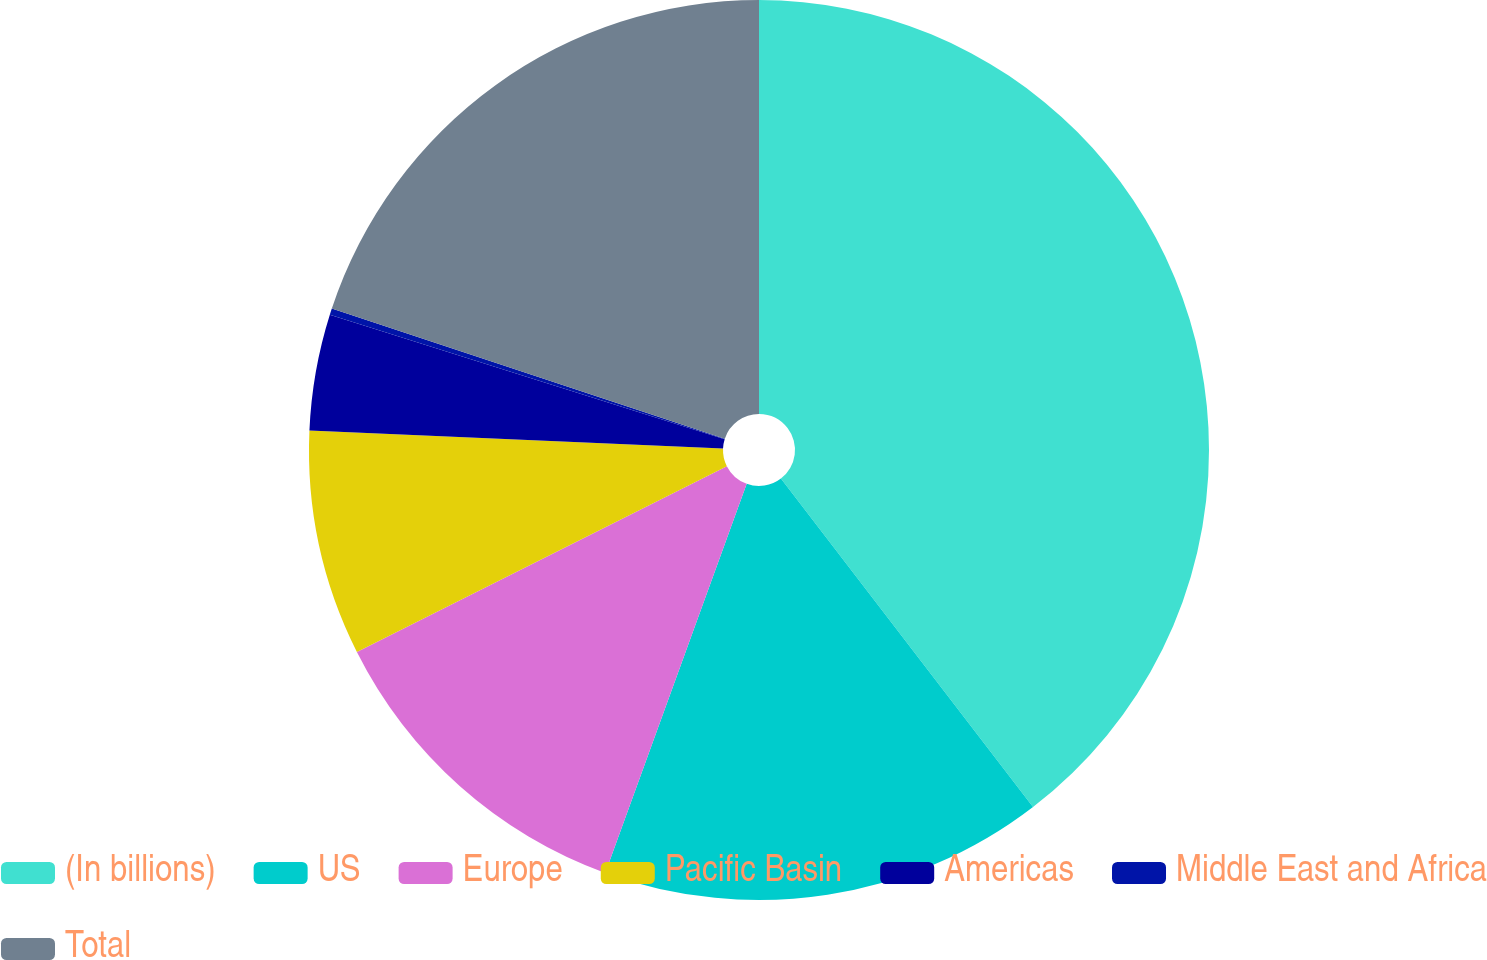<chart> <loc_0><loc_0><loc_500><loc_500><pie_chart><fcel>(In billions)<fcel>US<fcel>Europe<fcel>Pacific Basin<fcel>Americas<fcel>Middle East and Africa<fcel>Total<nl><fcel>39.58%<fcel>15.97%<fcel>12.04%<fcel>8.1%<fcel>4.17%<fcel>0.23%<fcel>19.91%<nl></chart> 